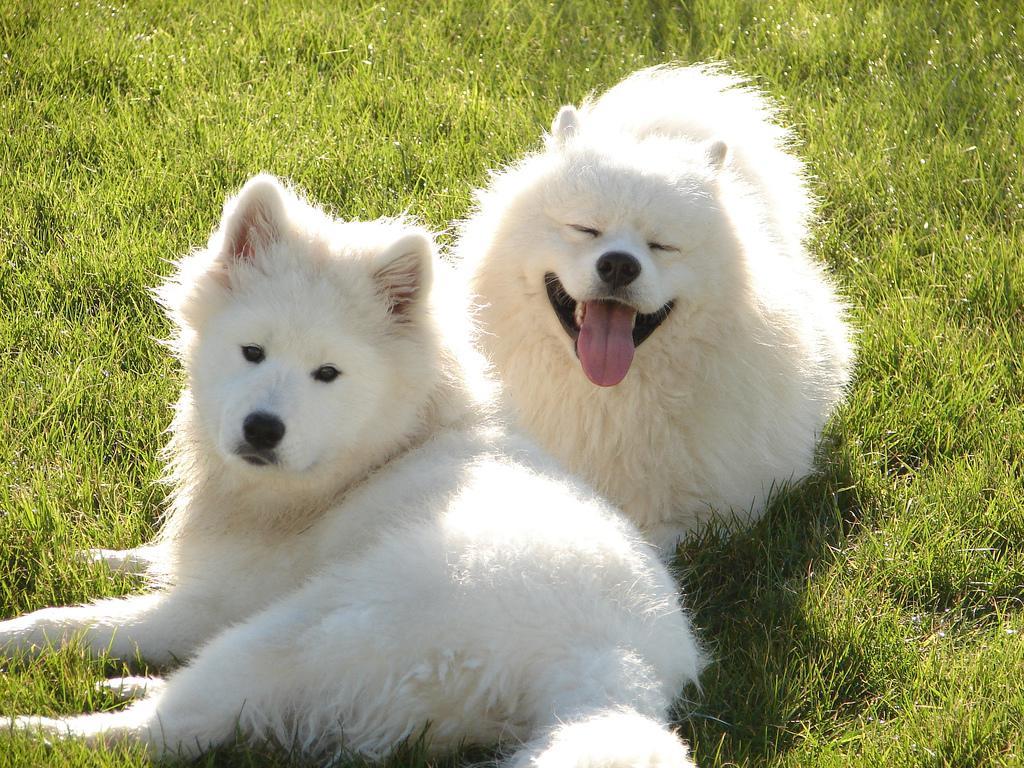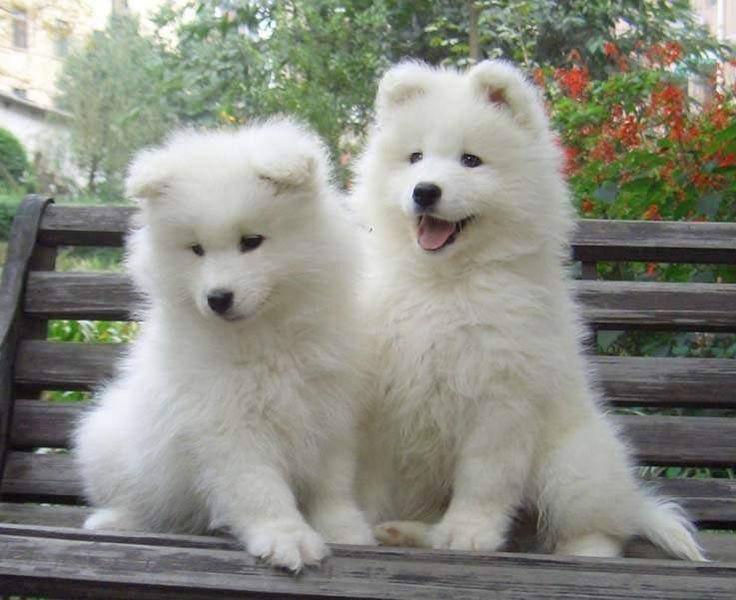The first image is the image on the left, the second image is the image on the right. Analyze the images presented: Is the assertion "Each image features two white dogs posed next to each other on green grass." valid? Answer yes or no. No. The first image is the image on the left, the second image is the image on the right. Considering the images on both sides, is "There are two white dogs in each image that are roughly the same age." valid? Answer yes or no. Yes. 